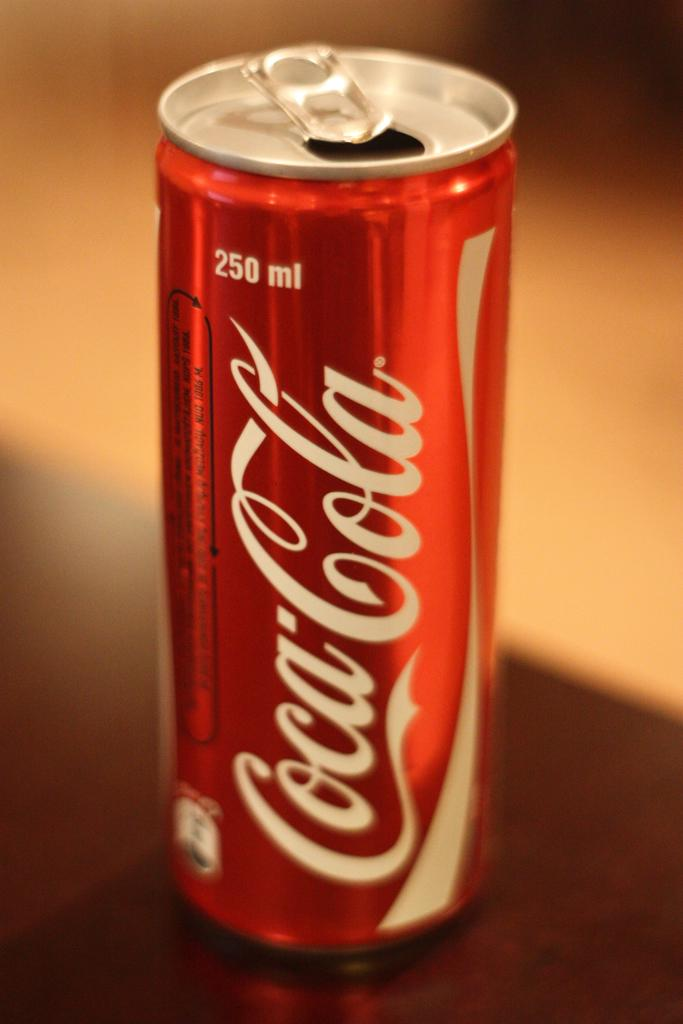<image>
Write a terse but informative summary of the picture. A Coca-cola can says that it contains 250 ml of soda. 